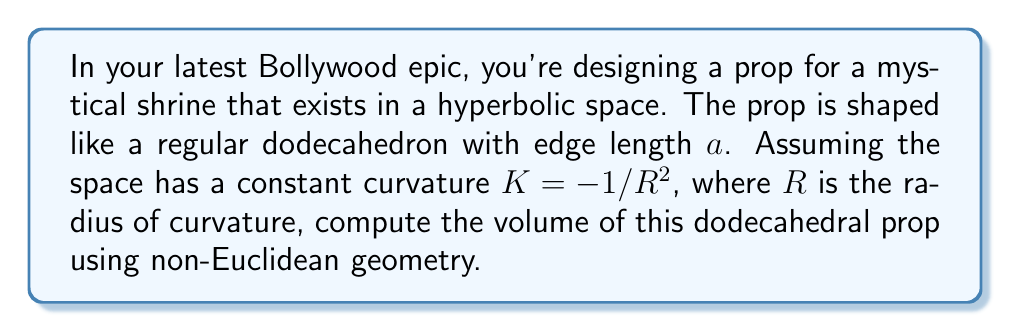What is the answer to this math problem? To solve this problem, we'll use the formula for the volume of a regular dodecahedron in hyperbolic space:

1) The volume formula for a regular dodecahedron in hyperbolic space is:

   $$V = \frac{5}{4}(3+\sqrt{5})R^3(\cosh(\frac{a}{R}) - 1)$$

   Where $R$ is the radius of curvature and $a$ is the edge length.

2) We're given that $K = -1/R^2$, so $R = 1/\sqrt{|K|}$

3) Substitute this into our volume formula:

   $$V = \frac{5}{4}(3+\sqrt{5})\frac{1}{|K|^{3/2}}(\cosh(a\sqrt{|K|}) - 1)$$

4) Now, we can simplify by letting $|K| = 1/R^2$:

   $$V = \frac{5}{4}(3+\sqrt{5})R^3(\cosh(\frac{a}{R}) - 1)$$

5) This is our final formula. To get a numerical answer, we would need specific values for $a$ and $R$.

[asy]
import geometry;

size(200);
pair A = (0,0), B = (1,0), C = (cos(72), sin(72));
path p = A--B--C--cycle;
draw(p);
draw(rotate(72)*p);
draw(rotate(144)*p);
draw(rotate(216)*p);
draw(rotate(288)*p);

label("$a$", (0.5,0), S);
[/asy]
Answer: $$V = \frac{5}{4}(3+\sqrt{5})R^3(\cosh(\frac{a}{R}) - 1)$$ 